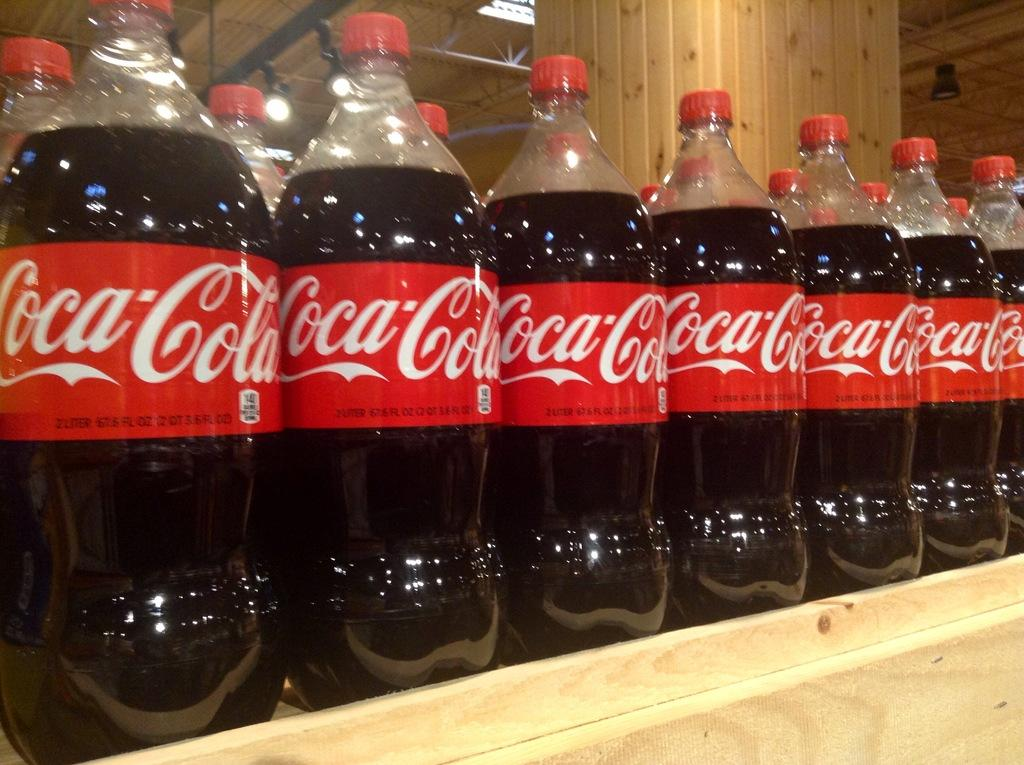What is on the desk in the image? There are coca cola bottles on a desk in the image. What can be seen on the ceiling in the image? There are lights and frames on the ceiling in the image. What is in the center of the background of the image? There is a pillar in the center of the background of the image. How many dolls are sitting on the pillar in the image? There are no dolls present in the image; it features coca cola bottles on a desk, lights and frames on the ceiling, and a pillar in the background. Are there any bikes visible in the image? There are no bikes present in the image. 